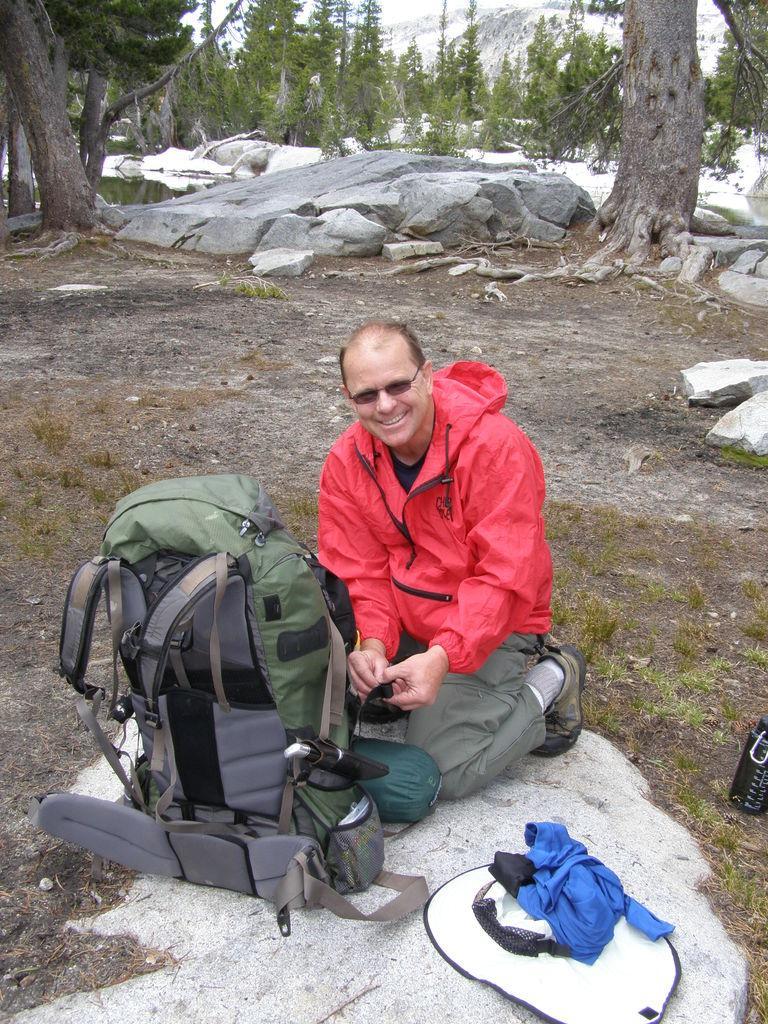Describe this image in one or two sentences. In the image we can see there is a man who is sitting and in front of him there is a travel backpack and he is wearing red colour jacket. At the back there are lot of trees. 